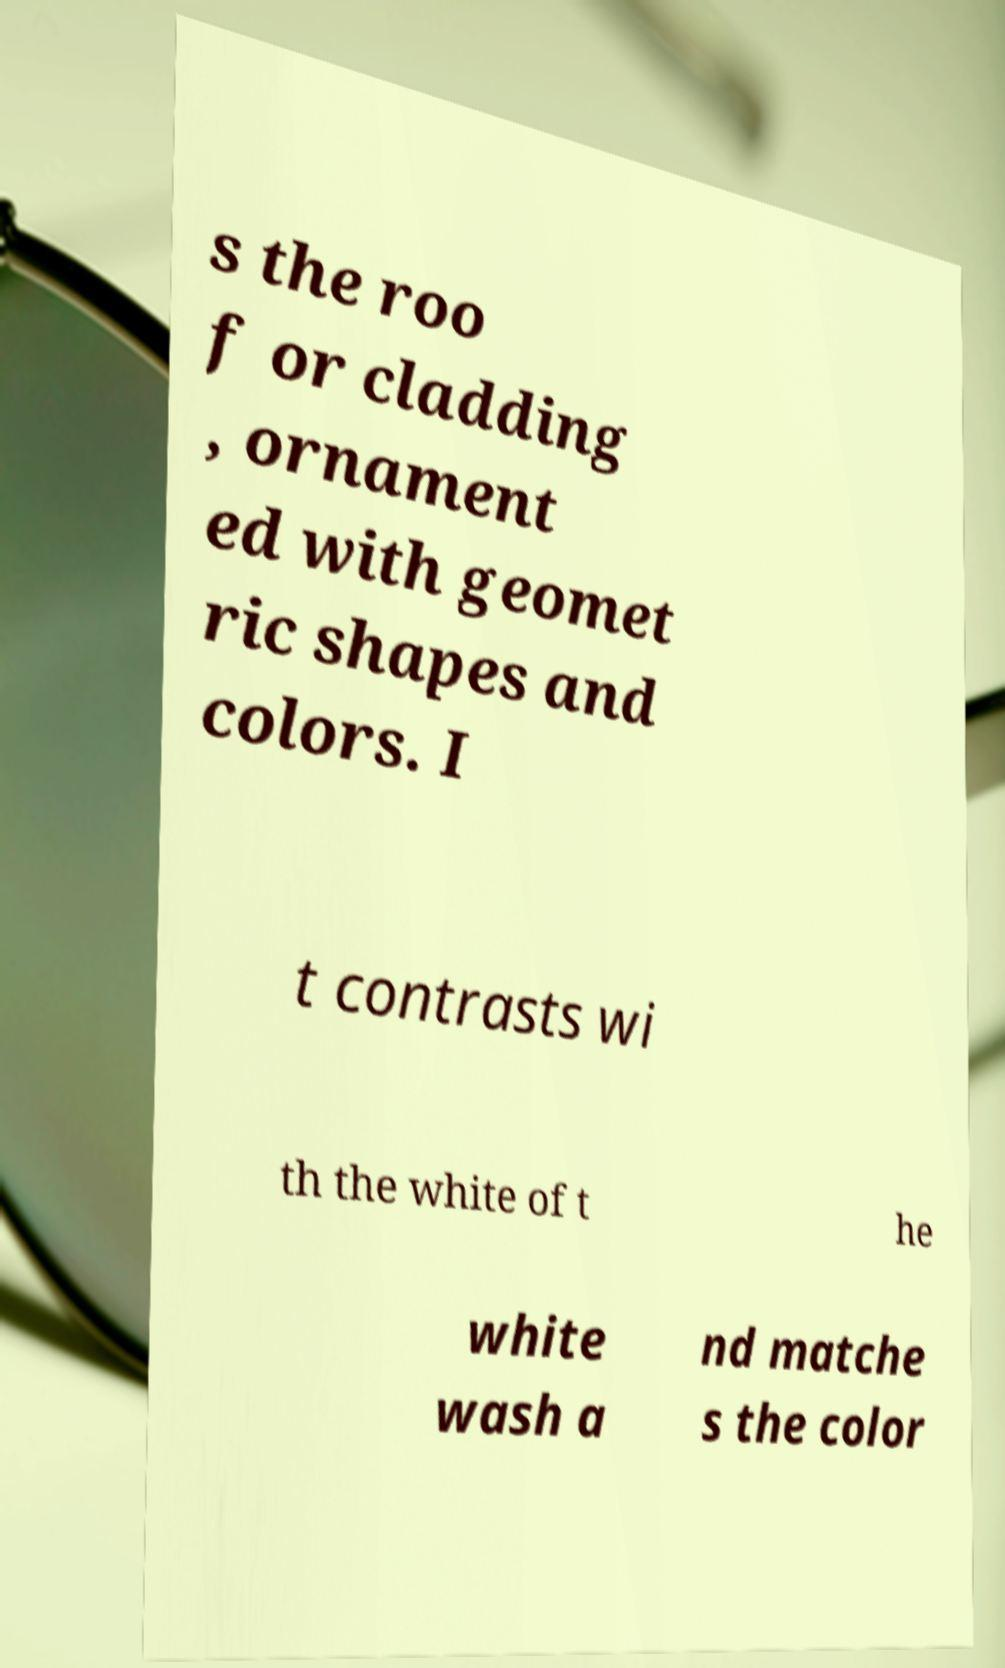There's text embedded in this image that I need extracted. Can you transcribe it verbatim? s the roo f or cladding , ornament ed with geomet ric shapes and colors. I t contrasts wi th the white of t he white wash a nd matche s the color 